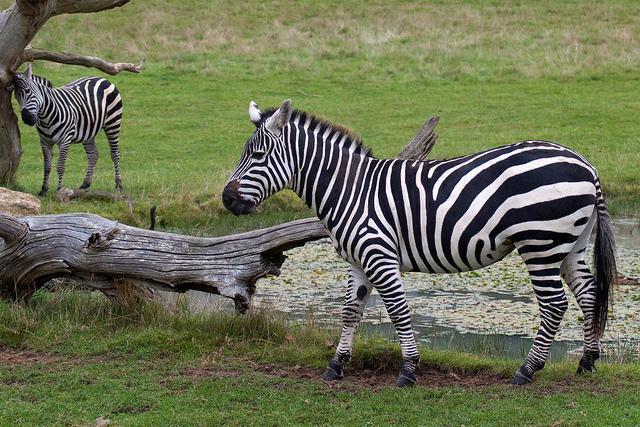How many zebras are there?
Give a very brief answer. 2. How many people in the shot?
Give a very brief answer. 0. 